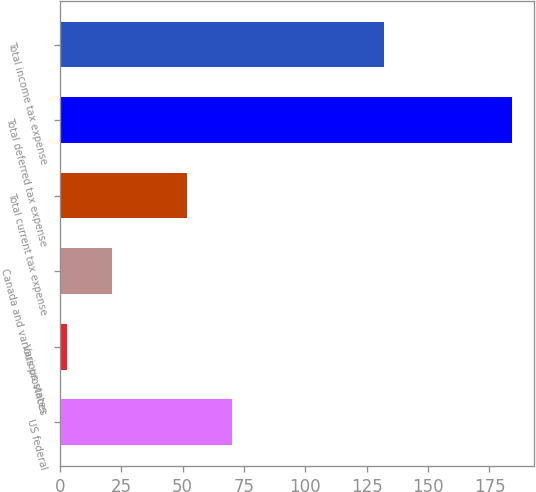Convert chart. <chart><loc_0><loc_0><loc_500><loc_500><bar_chart><fcel>US federal<fcel>Various states<fcel>Canada and various provinces<fcel>Total current tax expense<fcel>Total deferred tax expense<fcel>Total income tax expense<nl><fcel>70.1<fcel>3<fcel>21.1<fcel>52<fcel>184<fcel>132<nl></chart> 